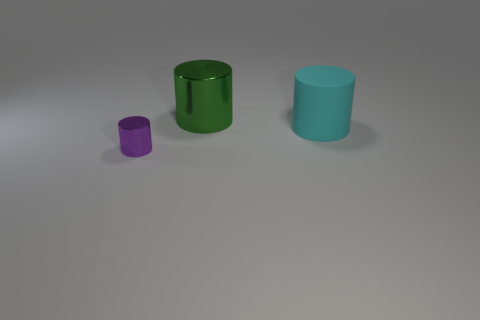How many other objects are the same size as the green cylinder?
Make the answer very short. 1. The shiny thing that is to the right of the tiny object in front of the big green shiny cylinder is what shape?
Keep it short and to the point. Cylinder. There is a metal cylinder on the right side of the small purple shiny object; is it the same color as the big cylinder in front of the green object?
Make the answer very short. No. Is there anything else that has the same color as the big matte cylinder?
Your answer should be very brief. No. What color is the big rubber cylinder?
Make the answer very short. Cyan. Is there a metal object?
Your answer should be very brief. Yes. Are there any green metal objects on the right side of the large matte thing?
Provide a short and direct response. No. There is another small object that is the same shape as the green metal object; what is its material?
Make the answer very short. Metal. Is there anything else that has the same material as the green thing?
Your answer should be very brief. Yes. What number of small metallic cylinders are right of the metal cylinder behind the thing in front of the cyan cylinder?
Offer a very short reply. 0. 